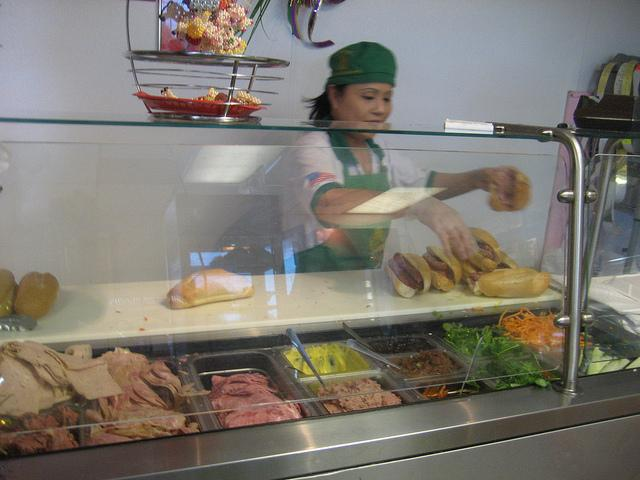What sort of specialty business is this?

Choices:
A) philly cheesesteak
B) fried chicken
C) pizza hut
D) sandwich shop sandwich shop 